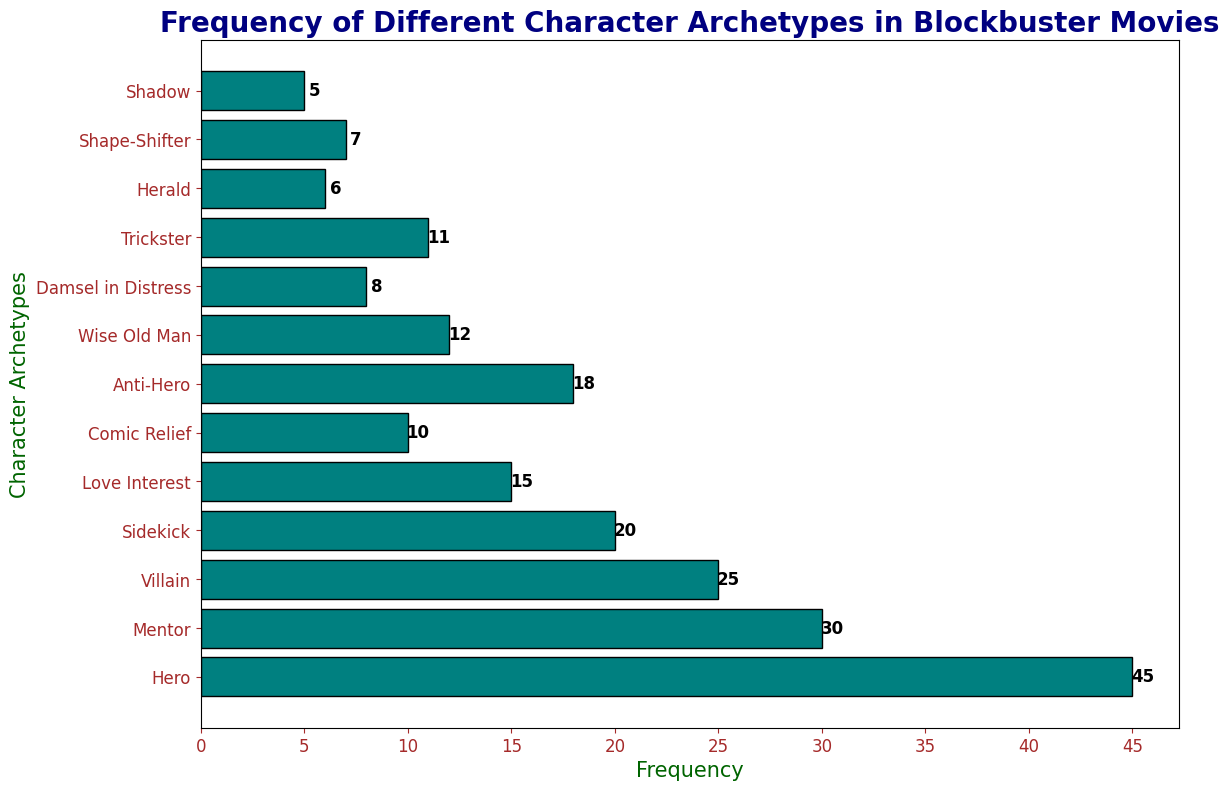What's the most frequent character archetype in blockbuster movies? The figure shows different archetypes along the y-axis with their corresponding frequencies indicated by the lengths of the bars. The longest bar corresponds to the "Hero" archetype with a frequency of 45.
Answer: Hero Which character archetype has the lowest frequency, and what is its frequency? By observing the lengths of the bars, the "Shadow" archetype has the shortest bar, indicating it has the lowest frequency of 5.
Answer: Shadow, 5 What is the combined frequency of the "Hero" and "Villain" archetypes? The frequencies of the "Hero" and "Villain" archetypes are 45 and 25 respectively. Adding these values gives 45 + 25 = 70.
Answer: 70 How much greater is the frequency of the "Hero" archetype compared to the "Comic Relief" archetype? The frequency of the "Hero" archetype is 45 and the "Comic Relief" archetype is 10. Subtracting these values gives 45 - 10 = 35.
Answer: 35 Which archetypes have a frequency greater than 20? By checking the bars that extend beyond the 20 mark on the x-axis, we see "Hero," "Mentor," and "Villain" archetypes have frequencies of 45, 30, and 25, respectively.
Answer: Hero, Mentor, Villain What is the average frequency of the "Anti-Hero", "Wise Old Man", and "Trickster" archetypes? The frequencies are: Anti-Hero (18), Wise Old Man (12), and Trickster (11). Adding them: 18 + 12 + 11 = 41. There are 3 archetypes, so the average is 41/3 ≈ 13.67.
Answer: 13.67 By how much does the frequency of the "Mentor" archetype exceed that of the "Damsel in Distress" archetype? The frequency of the "Mentor" archetype is 30, while the "Damsel in Distress" is 8. Subtracting these values gives 30 - 8 = 22.
Answer: 22 Which archetype has a frequency closer to that of the "Shape-Shifter": "Trickster" or "Wise Old Man"? The frequency of "Shape-Shifter" is 7. "Trickster" has a frequency of 11, which is a difference of 4. "Wise Old Man" has a frequency of 12, resulting in a difference of 5. Therefore, "Trickster" is closer.
Answer: Trickster What is the total frequency of all the character archetypes combined? Adding all frequencies: 45 (Hero) + 30 (Mentor) + 25 (Villain) + 20 (Sidekick) + 15 (Love Interest) + 10 (Comic Relief) + 18 (Anti-Hero) + 12 (Wise Old Man) + 8 (Damsel in Distress) + 11 (Trickster) + 6 (Herald) + 7 (Shape-Shifter) + 5 (Shadow) = 212.
Answer: 212 Which archetype has a frequency exactly equal to 15? By checking the lengths of the bars that correspond to a frequency of 15, the "Love Interest" archetype has this frequency.
Answer: Love Interest 